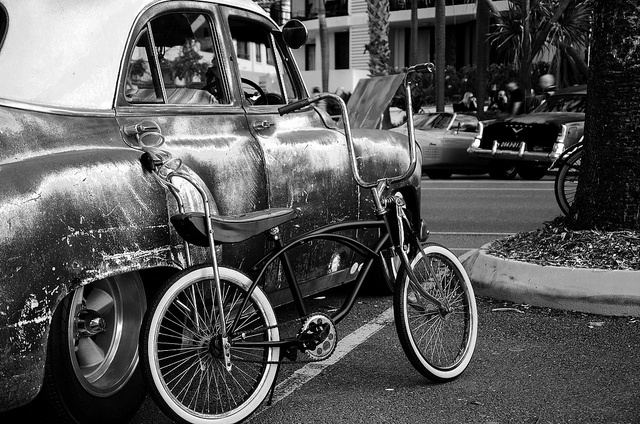Describe the objects in this image and their specific colors. I can see car in darkgray, black, lightgray, and gray tones, bicycle in darkgray, black, gray, and gainsboro tones, car in darkgray, black, gray, and white tones, car in darkgray, black, gray, and lightgray tones, and people in darkgray, black, gray, and lightgray tones in this image. 